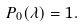Convert formula to latex. <formula><loc_0><loc_0><loc_500><loc_500>P _ { 0 } ( \lambda ) = 1 .</formula> 